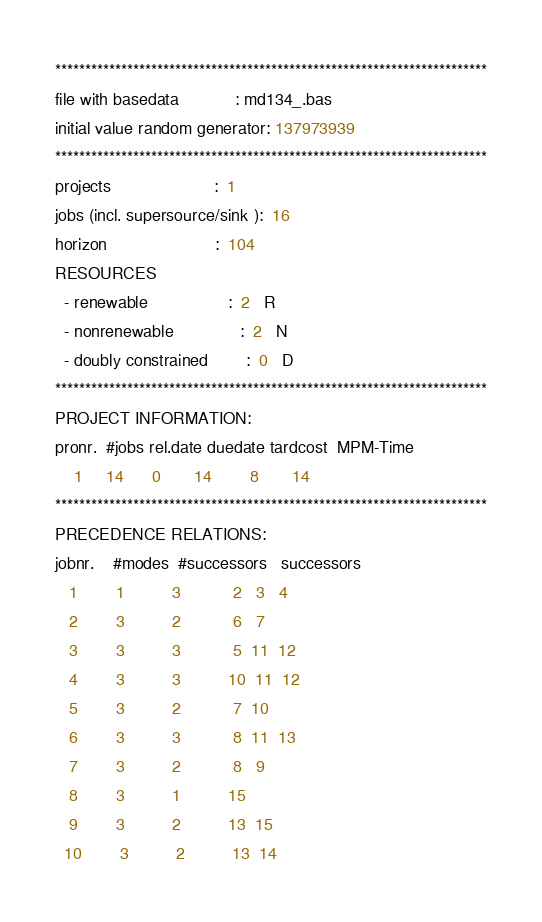Convert code to text. <code><loc_0><loc_0><loc_500><loc_500><_ObjectiveC_>************************************************************************
file with basedata            : md134_.bas
initial value random generator: 137973939
************************************************************************
projects                      :  1
jobs (incl. supersource/sink ):  16
horizon                       :  104
RESOURCES
  - renewable                 :  2   R
  - nonrenewable              :  2   N
  - doubly constrained        :  0   D
************************************************************************
PROJECT INFORMATION:
pronr.  #jobs rel.date duedate tardcost  MPM-Time
    1     14      0       14        8       14
************************************************************************
PRECEDENCE RELATIONS:
jobnr.    #modes  #successors   successors
   1        1          3           2   3   4
   2        3          2           6   7
   3        3          3           5  11  12
   4        3          3          10  11  12
   5        3          2           7  10
   6        3          3           8  11  13
   7        3          2           8   9
   8        3          1          15
   9        3          2          13  15
  10        3          2          13  14</code> 